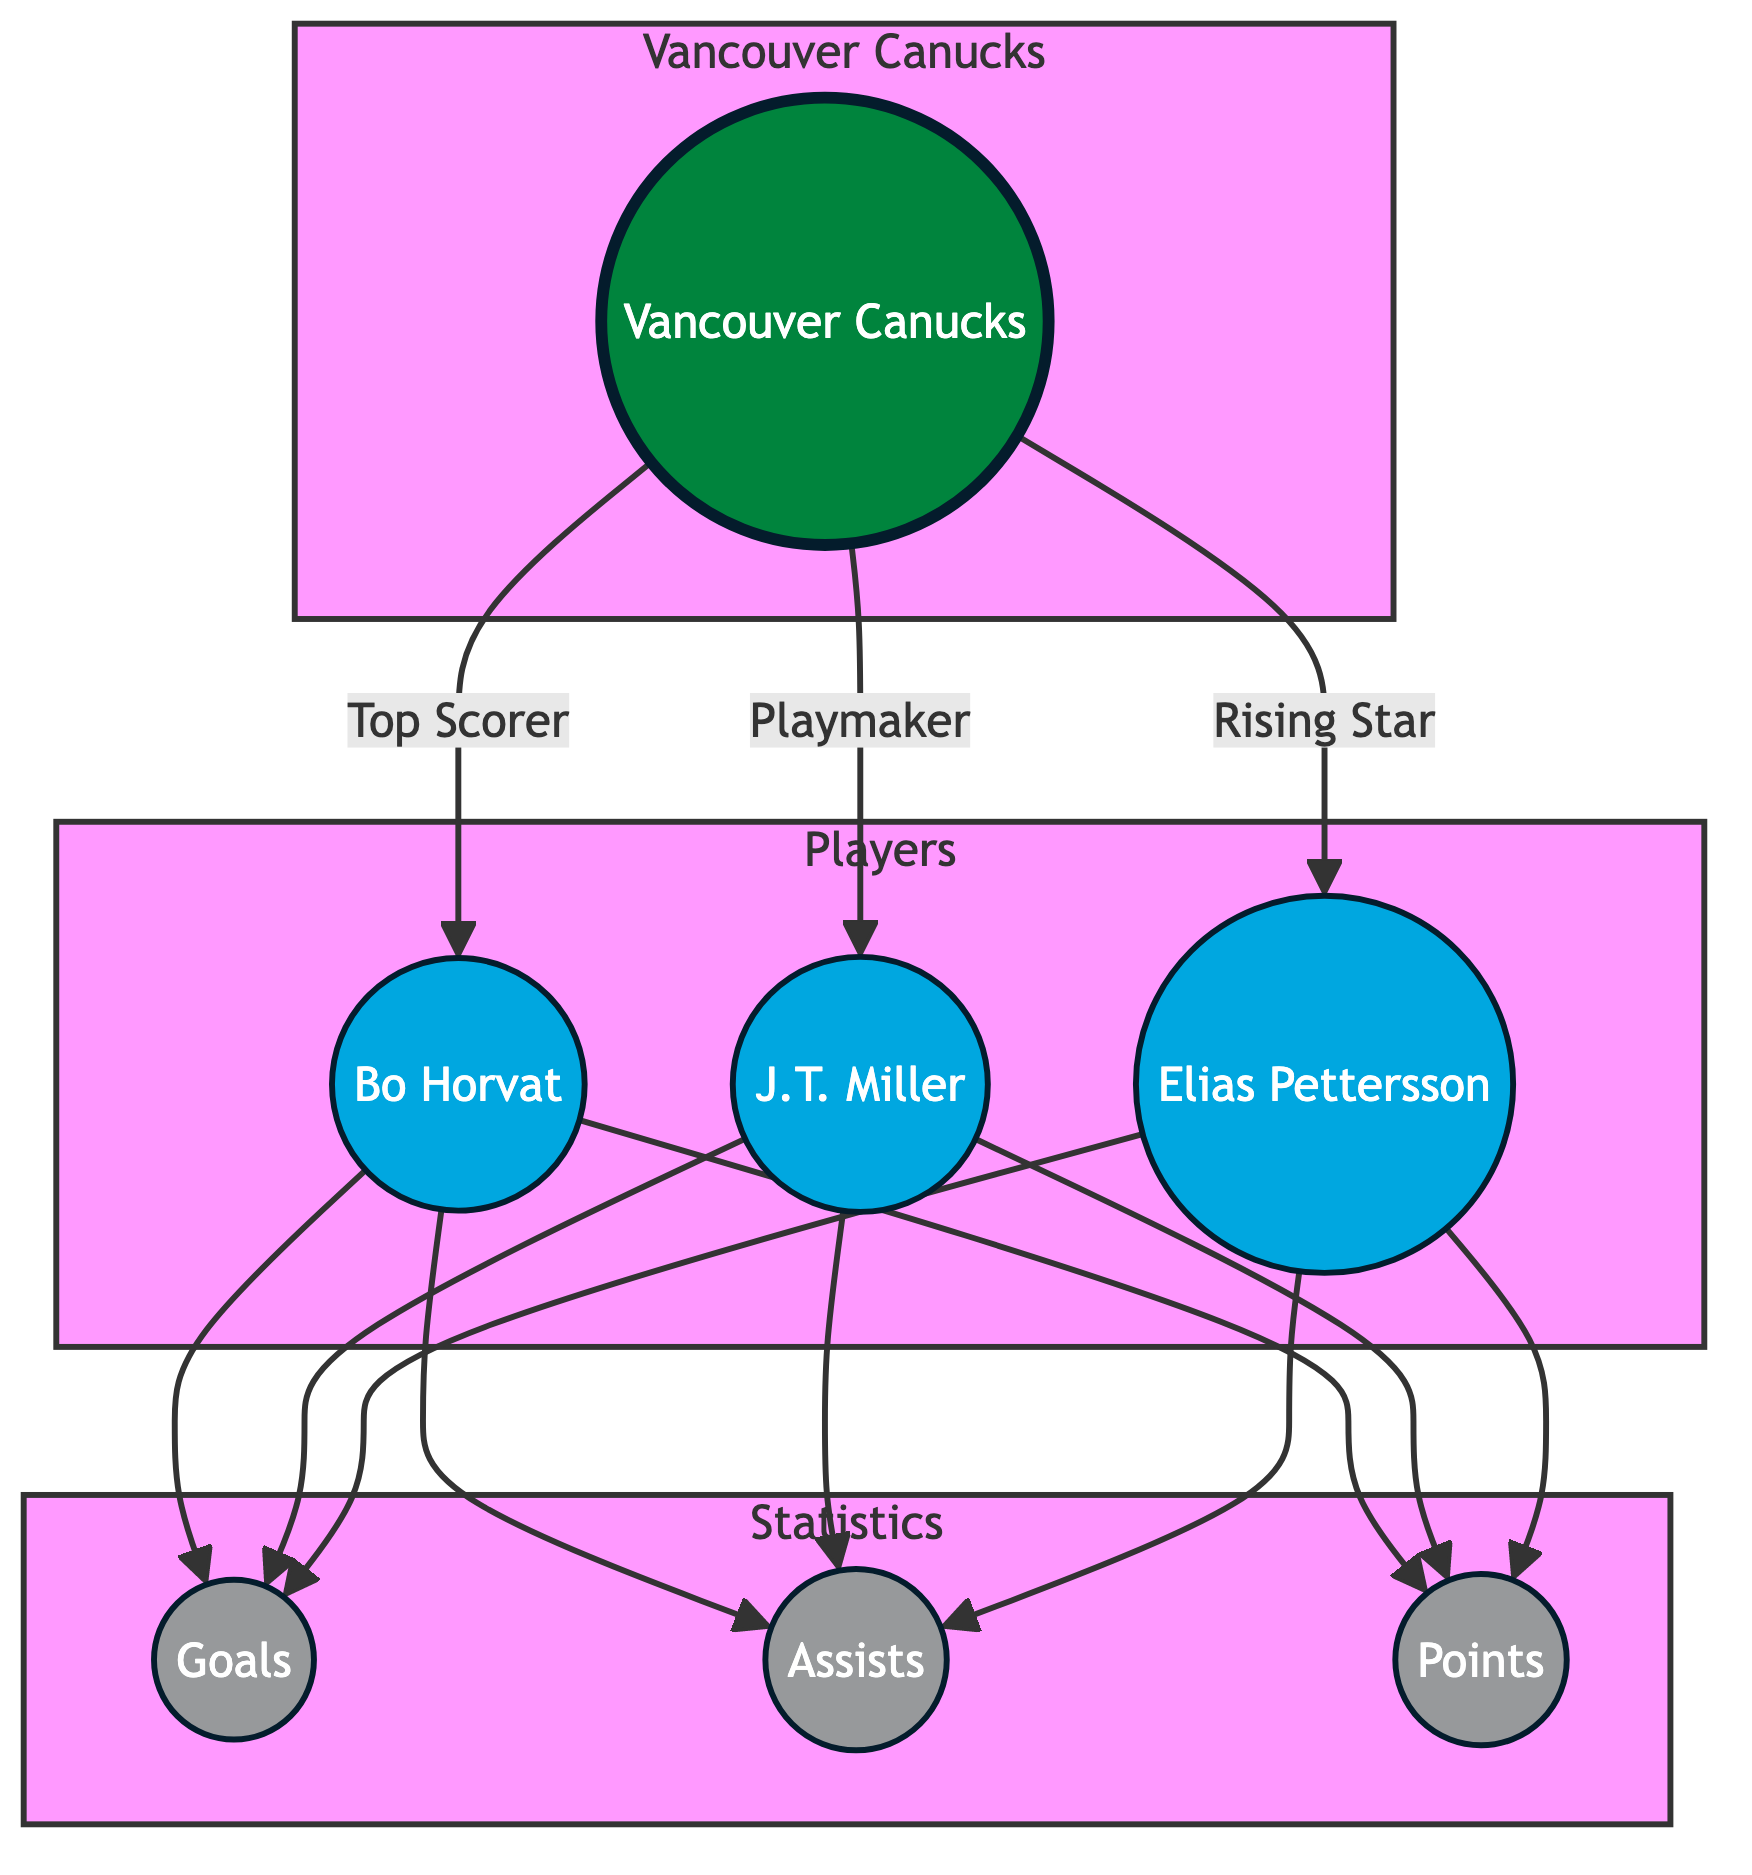What is the total number of players in the diagram? There are three players listed: Bo Horvat, J.T. Miller, and Elias Pettersson. Thus, the total count is simply the number of players presented in the diagram.
Answer: 3 Who is the top scorer for the Vancouver Canucks? The diagram indicates that Bo Horvat is labeled as the "Top Scorer" for the Canucks. This is a direct relationship from the Canucks node to the Horvat node, highlighting his scoring status.
Answer: Bo Horvat Which player is labeled as a playmaker? The diagram shows a directed edge from the Canucks node to J.T. Miller with the label "Playmaker," which explicitly identifies Miller in this role.
Answer: J.T. Miller How many statistics are directly linked to each player? Each of the three players has three statistics linked to them: goals, assists, and points. This means for every player in the diagram, there are three outgoing edges leading to these statistics.
Answer: 3 Which player contributes to points in addition to goals and assists? The diagram indicates that all three players (Horvat, Miller, and Pettersson) contribute to points. For each player, there is a direct edge leading from their node to the points statistic. Thus, the answer must include all mentioned players.
Answer: Bo Horvat, J.T. Miller, Elias Pettersson Which statistic has the most connections in the graph? In the diagram, goals, assists, and points each have exactly one connection from each player, leading to a total of three connections for each statistic. Therefore, all statistics are evenly connected.
Answer: Goals, Assists, Points What is the relationship between Elias Pettersson and the Vancouver Canucks? The directed edge from the Canucks node to Pettersson shows a direct relationship, labeling him as a "Rising Star," which identifies his significance within the team structure.
Answer: Rising Star How many edges connect players to individual statistics? Each of the three players has three outgoing edges to the statistics (goals, assists, points), thus the total edges in this section specific to player-stats connections are 3 players × 3 edges = 9 edges.
Answer: 9 